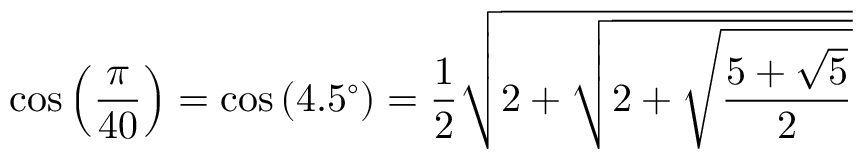<formula> <loc_0><loc_0><loc_500><loc_500>\cos \left ( { \frac { \pi } { 4 0 } } \right ) = \cos \left ( 4 . 5 ^ { \circ } \right ) = { \frac { 1 } { 2 } } { \sqrt { 2 + { \sqrt { 2 + { \sqrt { \frac { 5 + { \sqrt { 5 } } } { 2 } } } } } } }</formula> 